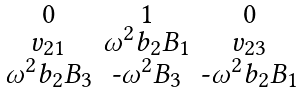Convert formula to latex. <formula><loc_0><loc_0><loc_500><loc_500>\begin{smallmatrix} 0 & 1 & 0 \\ v _ { 2 1 } & \omega ^ { 2 } b _ { 2 } B _ { 1 } & v _ { 2 3 } \\ \omega ^ { 2 } b _ { 2 } B _ { 3 } & \text {-} \omega ^ { 2 } B _ { 3 } & \text {-} \omega ^ { 2 } b _ { 2 } B _ { 1 } \end{smallmatrix}</formula> 